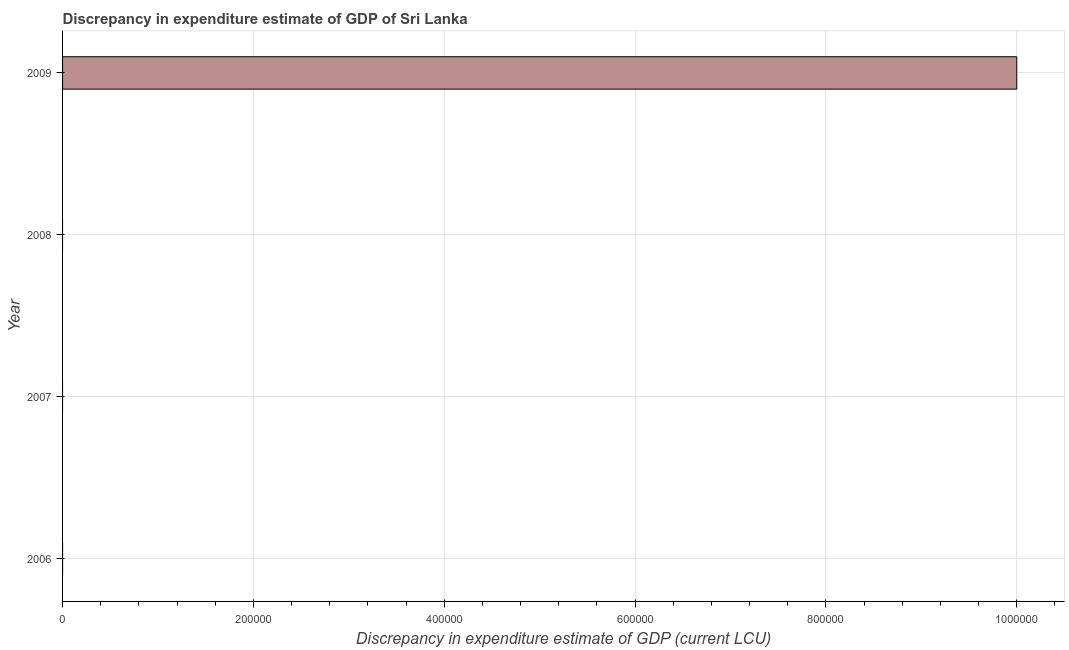Does the graph contain grids?
Offer a very short reply. Yes. What is the title of the graph?
Provide a short and direct response. Discrepancy in expenditure estimate of GDP of Sri Lanka. What is the label or title of the X-axis?
Keep it short and to the point. Discrepancy in expenditure estimate of GDP (current LCU). What is the discrepancy in expenditure estimate of gdp in 2008?
Offer a terse response. 0. Across all years, what is the maximum discrepancy in expenditure estimate of gdp?
Offer a terse response. 1.00e+06. Across all years, what is the minimum discrepancy in expenditure estimate of gdp?
Your response must be concise. 0. In which year was the discrepancy in expenditure estimate of gdp maximum?
Keep it short and to the point. 2009. What is the sum of the discrepancy in expenditure estimate of gdp?
Provide a short and direct response. 1.00e+06. What is the difference between the discrepancy in expenditure estimate of gdp in 2006 and 2009?
Your answer should be very brief. -1.00e+06. What is the average discrepancy in expenditure estimate of gdp per year?
Your answer should be very brief. 2.50e+05. What is the median discrepancy in expenditure estimate of gdp?
Your response must be concise. 0. What is the ratio of the discrepancy in expenditure estimate of gdp in 2006 to that in 2009?
Give a very brief answer. 0. Is the sum of the discrepancy in expenditure estimate of gdp in 2006 and 2009 greater than the maximum discrepancy in expenditure estimate of gdp across all years?
Make the answer very short. Yes. How many bars are there?
Give a very brief answer. 2. What is the difference between two consecutive major ticks on the X-axis?
Your response must be concise. 2.00e+05. What is the Discrepancy in expenditure estimate of GDP (current LCU) in 2006?
Ensure brevity in your answer.  0. What is the Discrepancy in expenditure estimate of GDP (current LCU) of 2007?
Your answer should be compact. 0. What is the Discrepancy in expenditure estimate of GDP (current LCU) in 2008?
Provide a short and direct response. 0. What is the Discrepancy in expenditure estimate of GDP (current LCU) of 2009?
Offer a very short reply. 1.00e+06. What is the difference between the Discrepancy in expenditure estimate of GDP (current LCU) in 2006 and 2009?
Make the answer very short. -1.00e+06. 